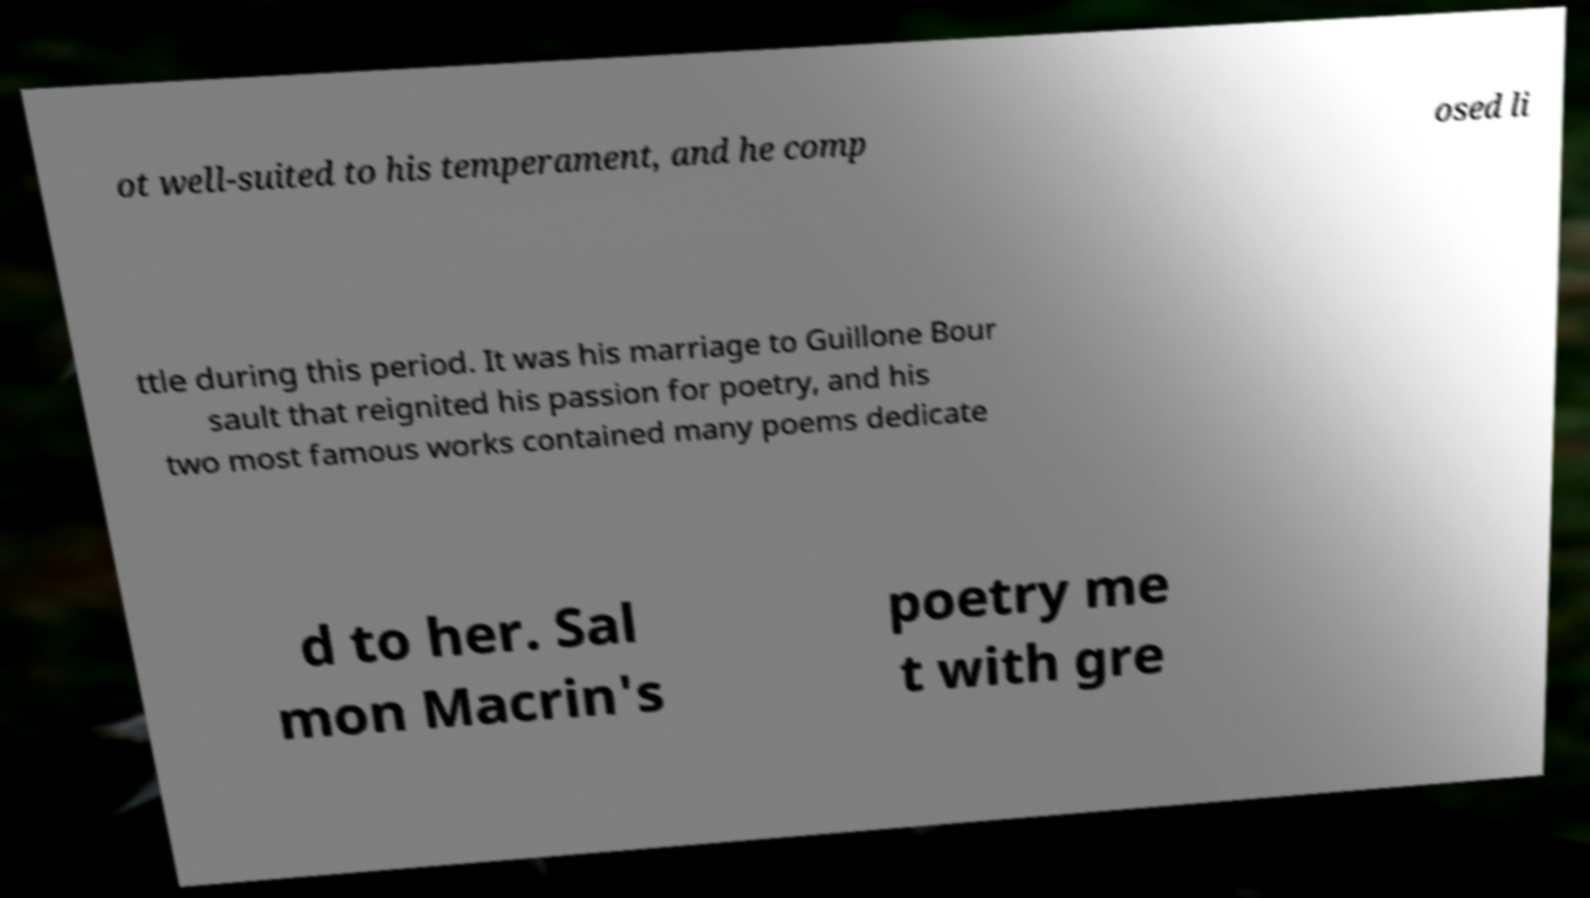Can you read and provide the text displayed in the image?This photo seems to have some interesting text. Can you extract and type it out for me? ot well-suited to his temperament, and he comp osed li ttle during this period. It was his marriage to Guillone Bour sault that reignited his passion for poetry, and his two most famous works contained many poems dedicate d to her. Sal mon Macrin's poetry me t with gre 